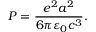Convert formula to latex. <formula><loc_0><loc_0><loc_500><loc_500>P = { \frac { e ^ { 2 } a ^ { 2 } } { 6 \pi \varepsilon _ { 0 } c ^ { 3 } } } .</formula> 